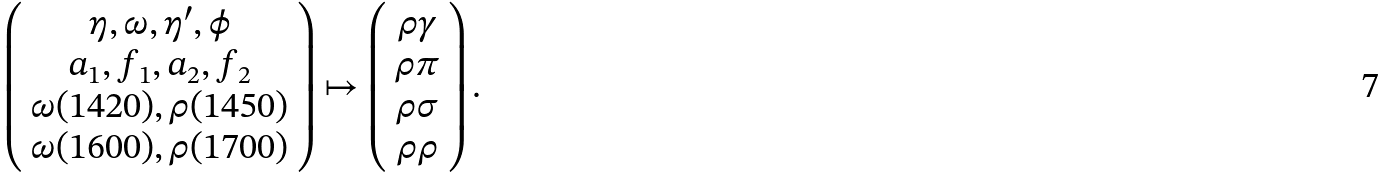<formula> <loc_0><loc_0><loc_500><loc_500>\left ( \begin{array} { c } \eta , \omega , \eta ^ { \prime } , \phi \\ a _ { 1 } , f _ { 1 } , a _ { 2 } , f _ { 2 } \\ \omega ( 1 4 2 0 ) , \rho ( 1 4 5 0 ) \\ \omega ( 1 6 0 0 ) , \rho ( 1 7 0 0 ) \end{array} \right ) \mapsto \left ( \begin{array} { c } \rho \gamma \\ \rho \pi \\ \rho \sigma \\ \rho \rho \end{array} \right ) .</formula> 